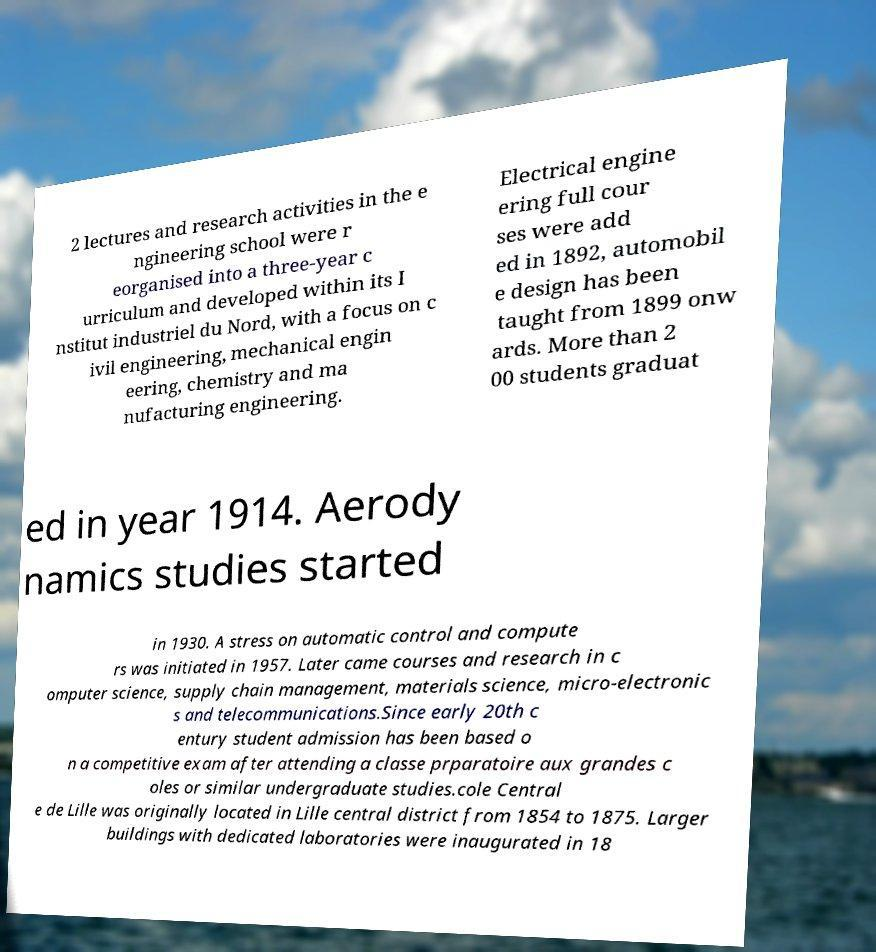Please read and relay the text visible in this image. What does it say? 2 lectures and research activities in the e ngineering school were r eorganised into a three-year c urriculum and developed within its I nstitut industriel du Nord, with a focus on c ivil engineering, mechanical engin eering, chemistry and ma nufacturing engineering. Electrical engine ering full cour ses were add ed in 1892, automobil e design has been taught from 1899 onw ards. More than 2 00 students graduat ed in year 1914. Aerody namics studies started in 1930. A stress on automatic control and compute rs was initiated in 1957. Later came courses and research in c omputer science, supply chain management, materials science, micro-electronic s and telecommunications.Since early 20th c entury student admission has been based o n a competitive exam after attending a classe prparatoire aux grandes c oles or similar undergraduate studies.cole Central e de Lille was originally located in Lille central district from 1854 to 1875. Larger buildings with dedicated laboratories were inaugurated in 18 